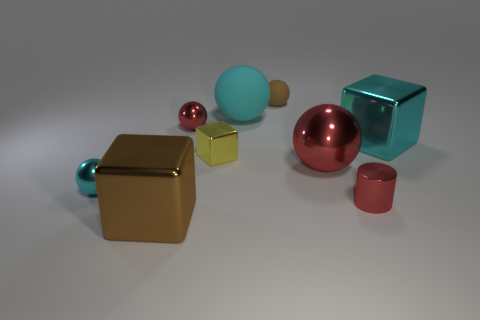What is the material of the tiny cylinder?
Provide a succinct answer. Metal. How many blocks are left of the cyan cube?
Provide a succinct answer. 2. Does the cylinder have the same color as the large shiny sphere?
Your answer should be very brief. Yes. How many cubes have the same color as the small matte object?
Your answer should be compact. 1. Are there more small metal spheres than cyan cubes?
Give a very brief answer. Yes. What is the size of the object that is both in front of the big red thing and on the right side of the brown matte object?
Offer a very short reply. Small. Do the cyan ball that is on the right side of the small yellow metallic block and the red ball to the right of the tiny red shiny sphere have the same material?
Your answer should be very brief. No. There is a matte thing that is the same size as the cyan shiny block; what is its shape?
Your response must be concise. Sphere. Is the number of tiny brown objects less than the number of big cubes?
Ensure brevity in your answer.  Yes. Are there any small yellow metallic things behind the brown object in front of the yellow metallic thing?
Keep it short and to the point. Yes. 